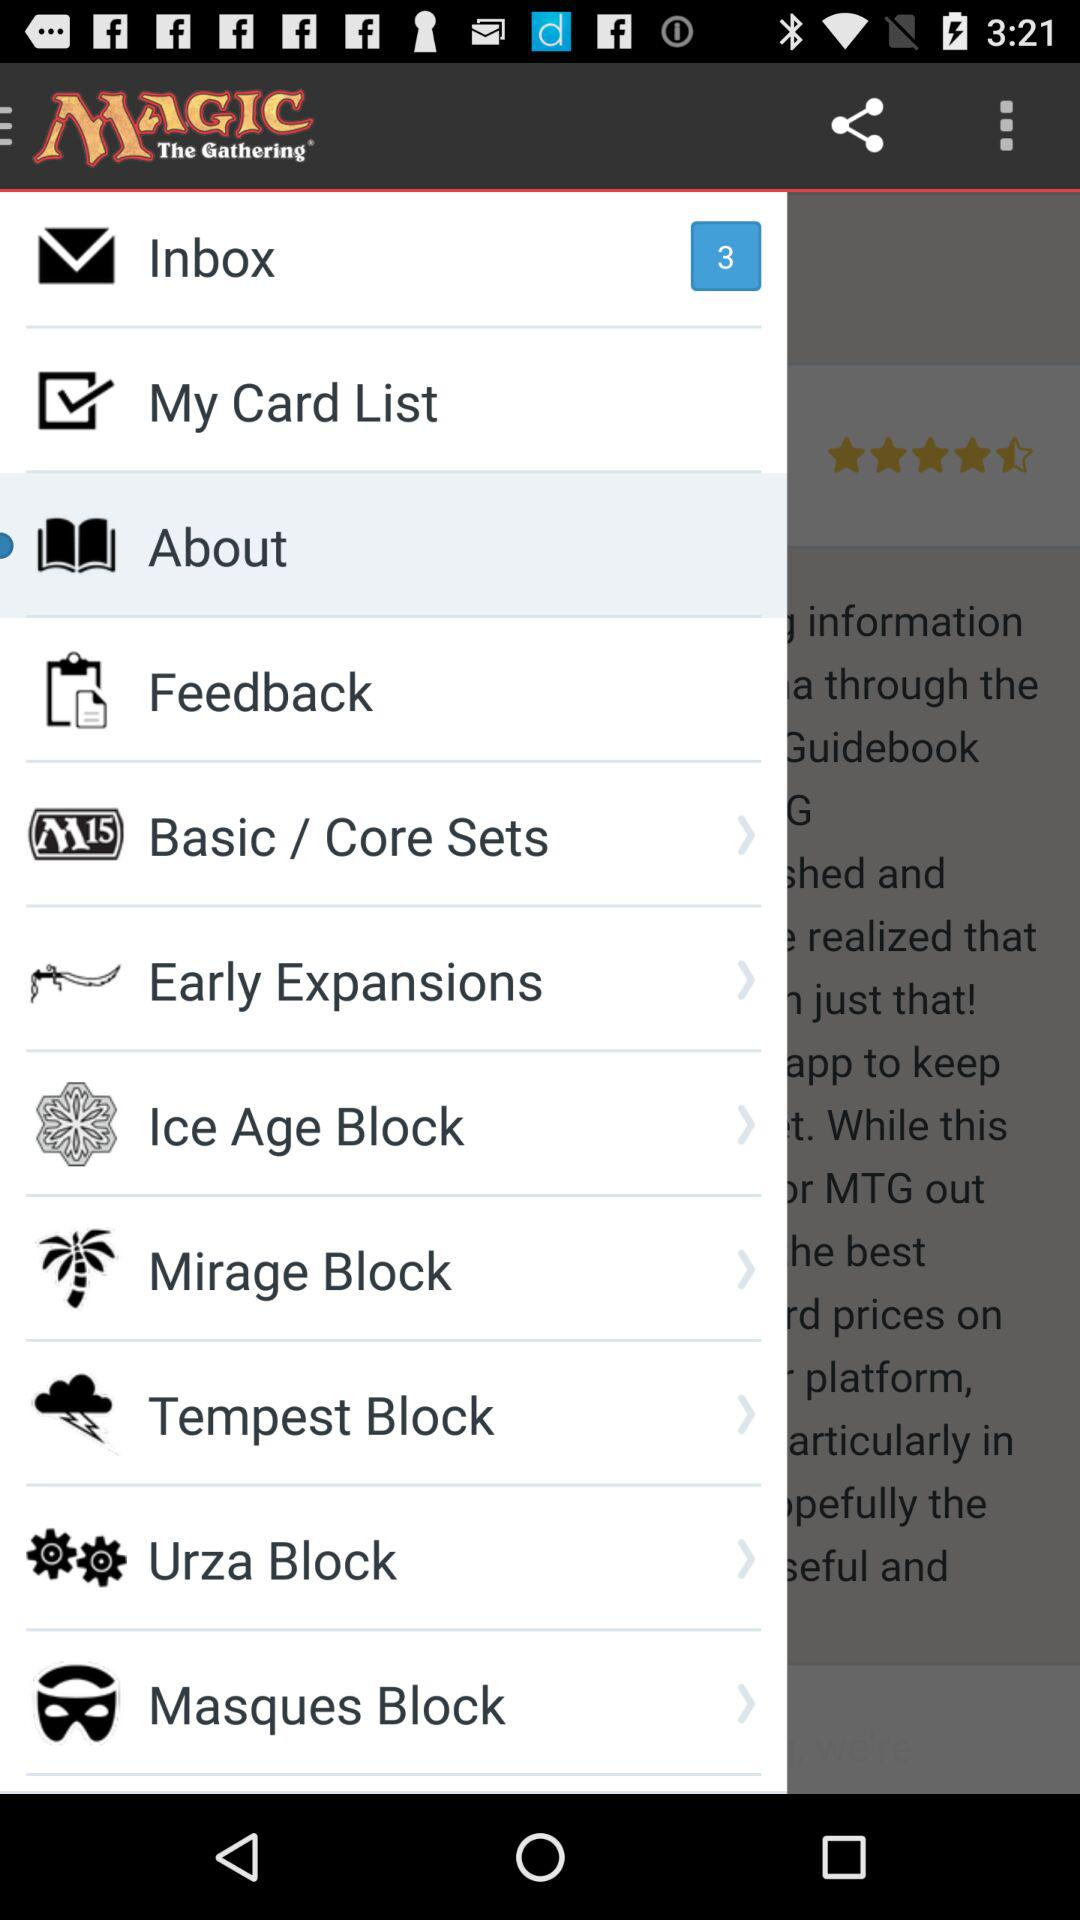What is the name of the application? The name of the application is "MAGIC The Gathering". 